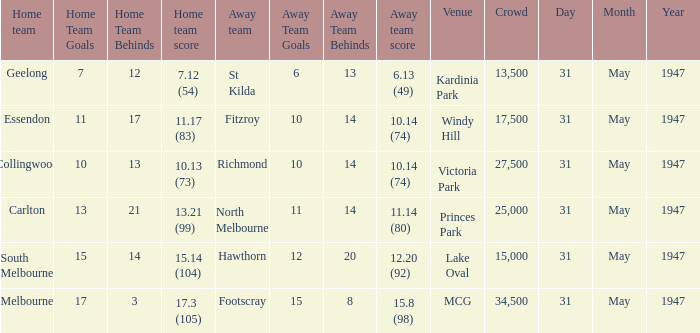Give me the full table as a dictionary. {'header': ['Home team', 'Home Team Goals', 'Home Team Behinds', 'Home team score', 'Away team', 'Away Team Goals', 'Away Team Behinds', 'Away team score', 'Venue', 'Crowd', 'Day', 'Month', 'Year'], 'rows': [['Geelong', '7', '12', '7.12 (54)', 'St Kilda', '6', '13', '6.13 (49)', 'Kardinia Park', '13,500', '31', 'May', '1947'], ['Essendon', '11', '17', '11.17 (83)', 'Fitzroy', '10', '14', '10.14 (74)', 'Windy Hill', '17,500', '31', 'May', '1947'], ['Collingwood', '10', '13', '10.13 (73)', 'Richmond', '10', '14', '10.14 (74)', 'Victoria Park', '27,500', '31', 'May', '1947'], ['Carlton', '13', '21', '13.21 (99)', 'North Melbourne', '11', '14', '11.14 (80)', 'Princes Park', '25,000', '31', 'May', '1947'], ['South Melbourne', '15', '14', '15.14 (104)', 'Hawthorn', '12', '20', '12.20 (92)', 'Lake Oval', '15,000', '31', 'May', '1947'], ['Melbourne', '17', '3', '17.3 (105)', 'Footscray', '15', '8', '15.8 (98)', 'MCG', '34,500', '31', 'May', '1947']]} What day is south melbourne at home? 31 May 1947. 